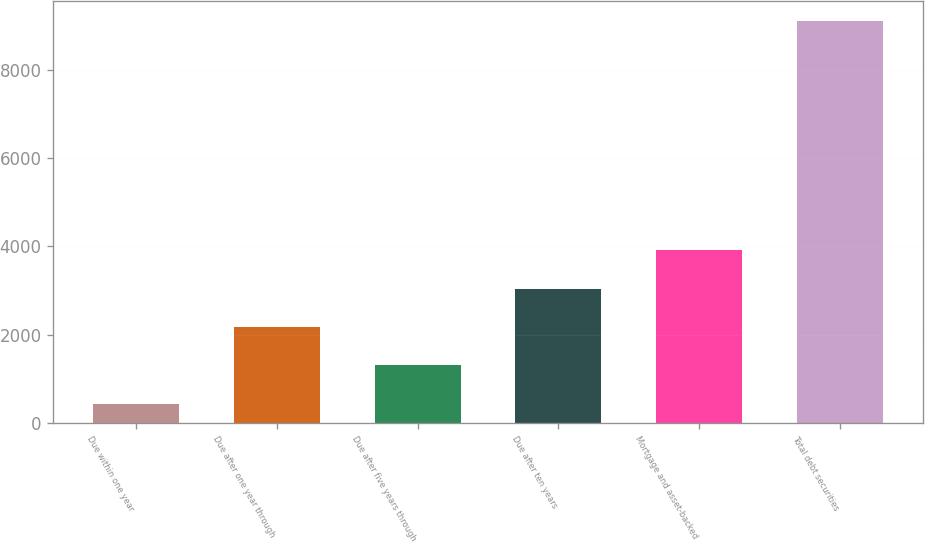Convert chart to OTSL. <chart><loc_0><loc_0><loc_500><loc_500><bar_chart><fcel>Due within one year<fcel>Due after one year through<fcel>Due after five years through<fcel>Due after ten years<fcel>Mortgage and asset-backed<fcel>Total debt securities<nl><fcel>439<fcel>2173.2<fcel>1306.1<fcel>3040.3<fcel>3907.4<fcel>9110<nl></chart> 